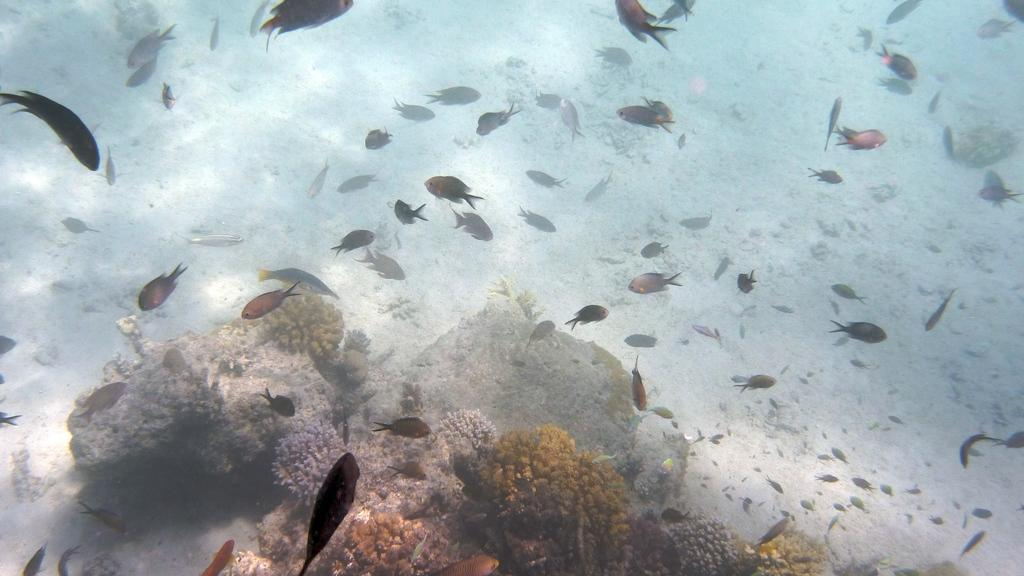What is the setting of the image? The image shows a view inside the water. What types of vegetation can be seen in the image? There are water plants visible in the image. What else is present in the image besides water plants? Rocks and stones are present in the image. What kind of aquatic animals can be seen in the image? Different types of fishes are visible in the image. What type of underwear is the fish wearing in the image? There is no underwear present in the image, as it features a view inside the water with fishes and other elements. 